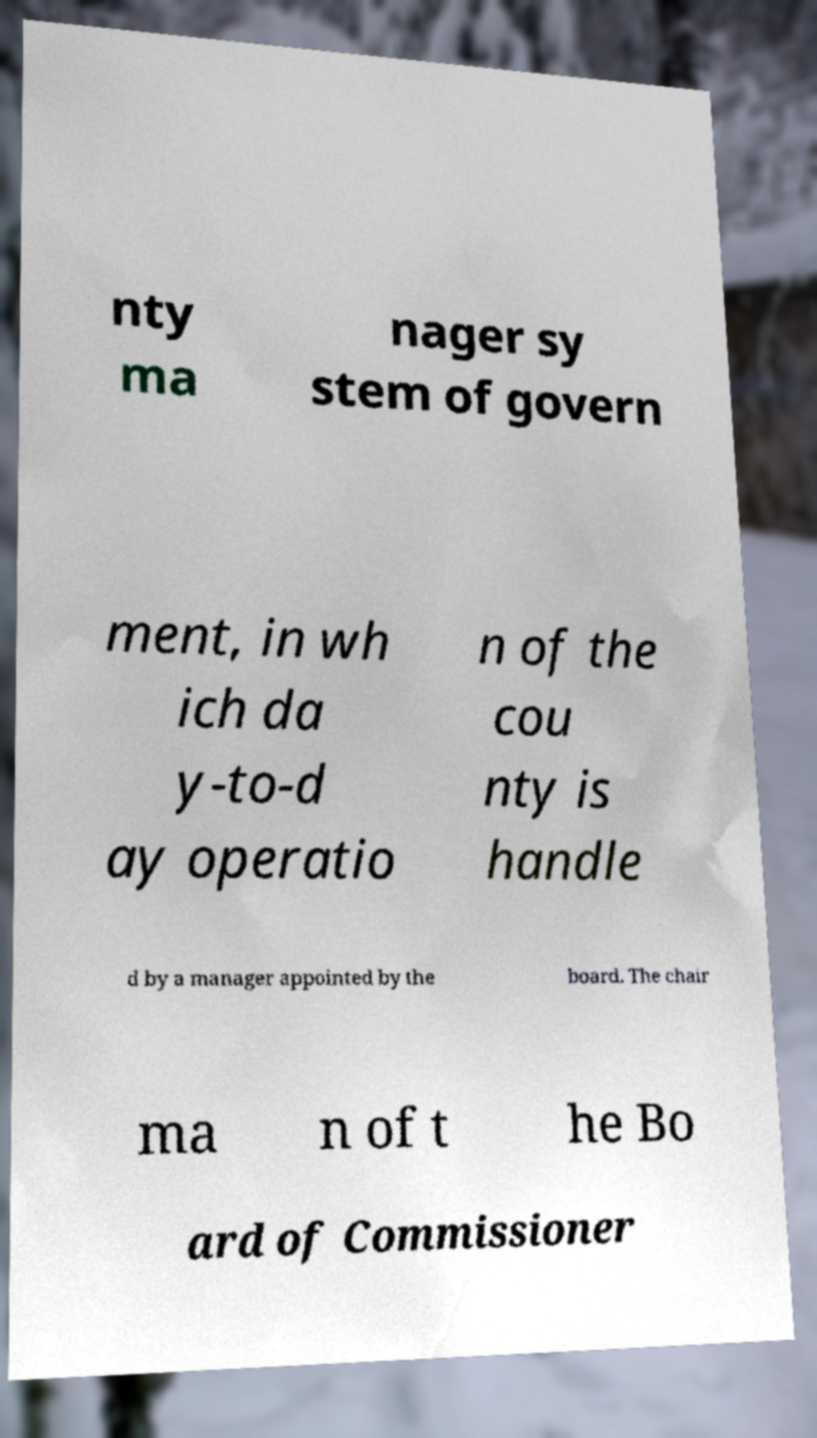Please identify and transcribe the text found in this image. nty ma nager sy stem of govern ment, in wh ich da y-to-d ay operatio n of the cou nty is handle d by a manager appointed by the board. The chair ma n of t he Bo ard of Commissioner 